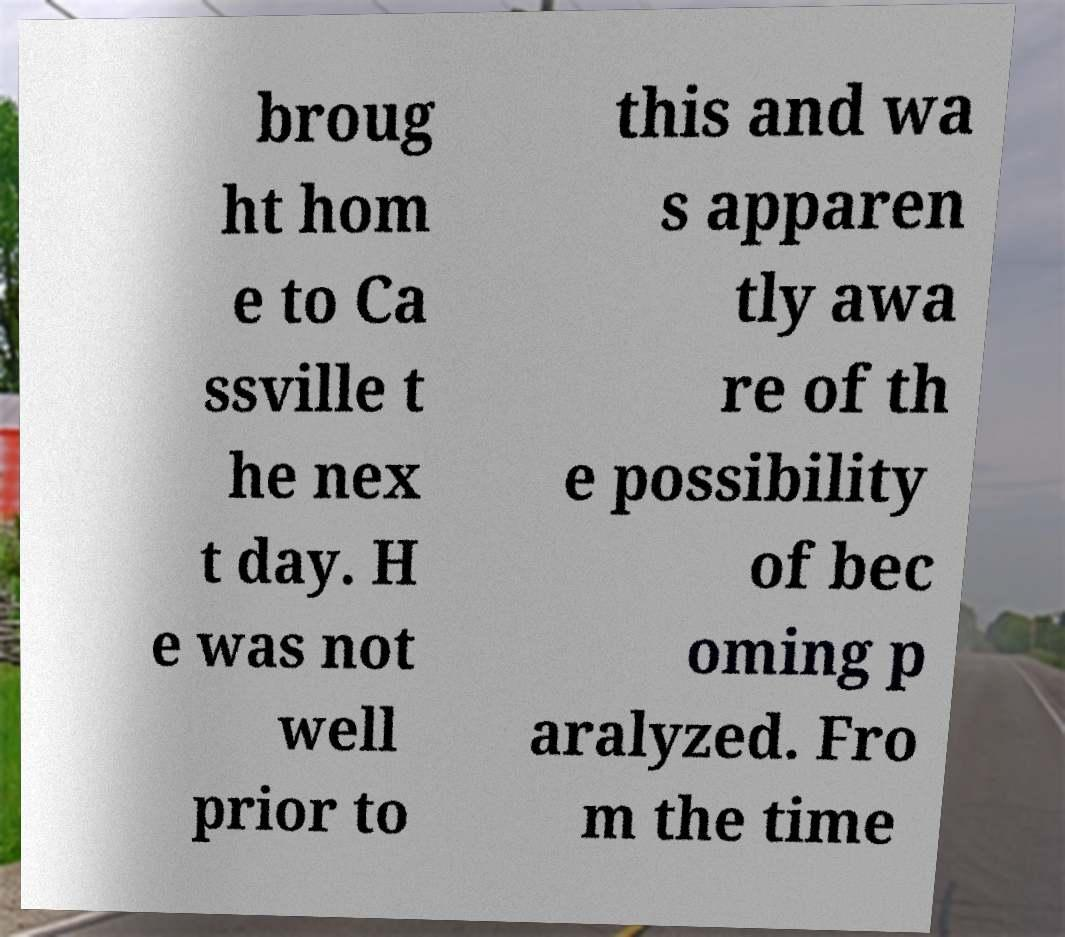Could you assist in decoding the text presented in this image and type it out clearly? broug ht hom e to Ca ssville t he nex t day. H e was not well prior to this and wa s apparen tly awa re of th e possibility of bec oming p aralyzed. Fro m the time 